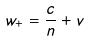<formula> <loc_0><loc_0><loc_500><loc_500>w _ { + } = \frac { c } { n } + v</formula> 